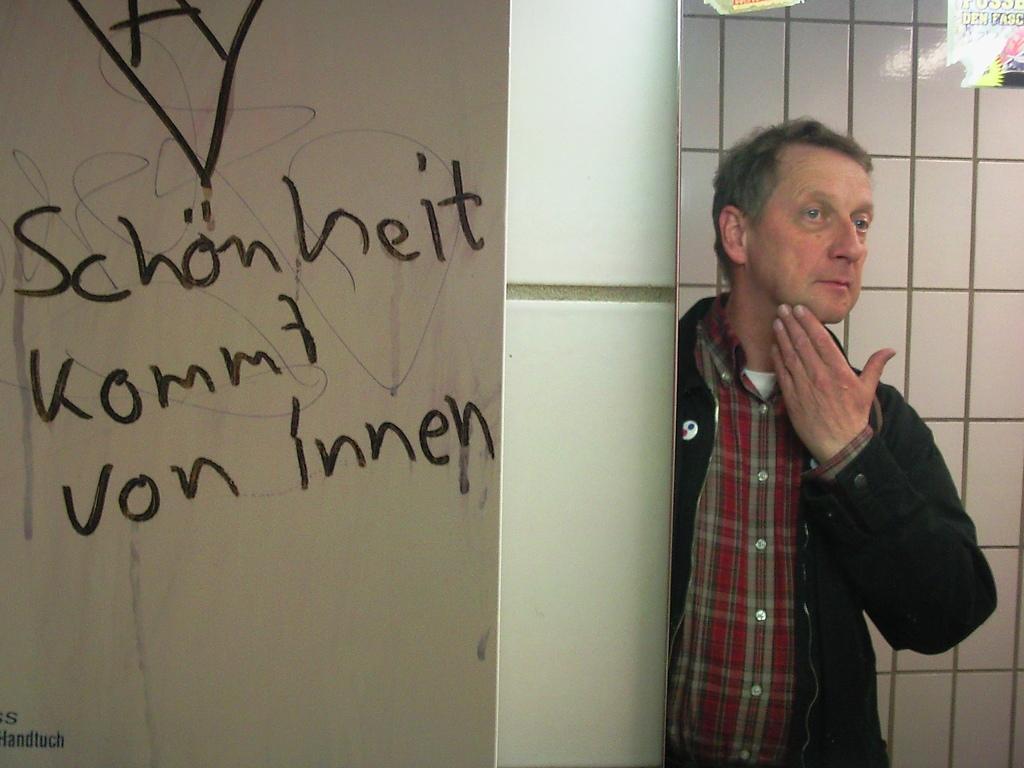Describe this image in one or two sentences. In this image on the right there is a man, he wears a jacket, shirt. On the left there is a board on that there is a text. In the middle there is a wall. At the top there is a poster and text. 